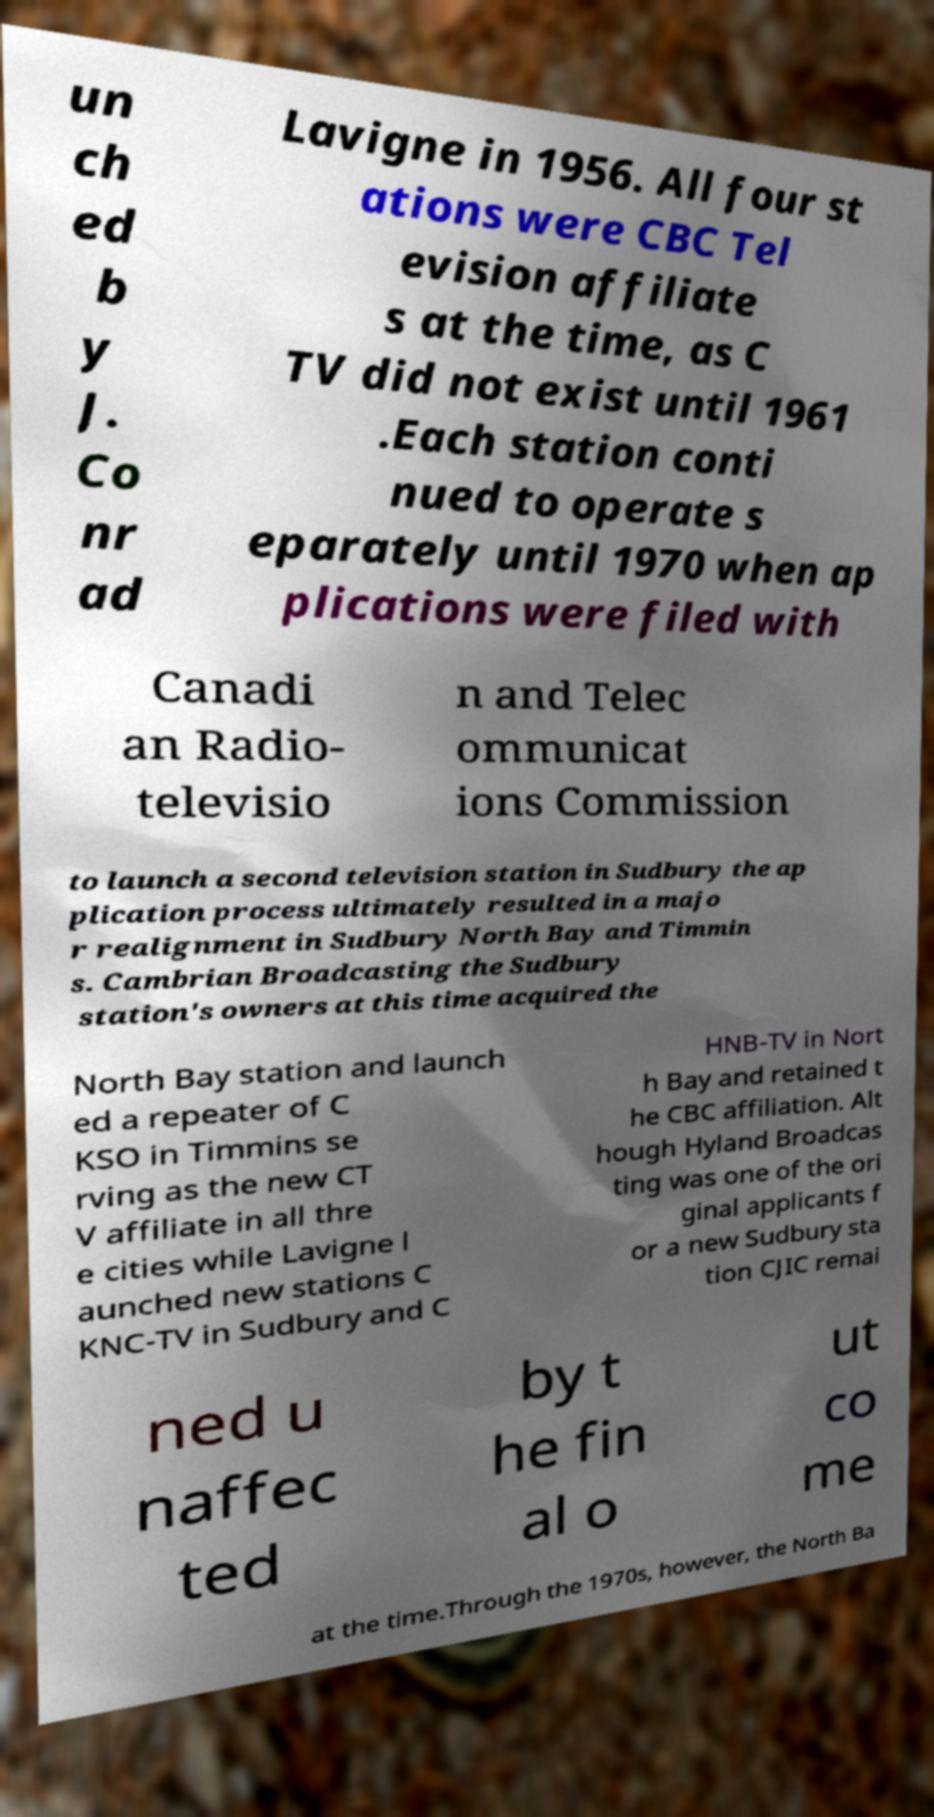There's text embedded in this image that I need extracted. Can you transcribe it verbatim? un ch ed b y J. Co nr ad Lavigne in 1956. All four st ations were CBC Tel evision affiliate s at the time, as C TV did not exist until 1961 .Each station conti nued to operate s eparately until 1970 when ap plications were filed with Canadi an Radio- televisio n and Telec ommunicat ions Commission to launch a second television station in Sudbury the ap plication process ultimately resulted in a majo r realignment in Sudbury North Bay and Timmin s. Cambrian Broadcasting the Sudbury station's owners at this time acquired the North Bay station and launch ed a repeater of C KSO in Timmins se rving as the new CT V affiliate in all thre e cities while Lavigne l aunched new stations C KNC-TV in Sudbury and C HNB-TV in Nort h Bay and retained t he CBC affiliation. Alt hough Hyland Broadcas ting was one of the ori ginal applicants f or a new Sudbury sta tion CJIC remai ned u naffec ted by t he fin al o ut co me at the time.Through the 1970s, however, the North Ba 